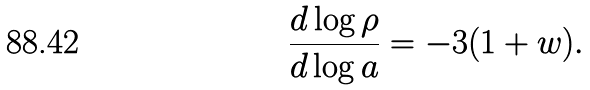<formula> <loc_0><loc_0><loc_500><loc_500>\frac { d \log \rho } { d \log a } = - 3 ( 1 + w ) .</formula> 